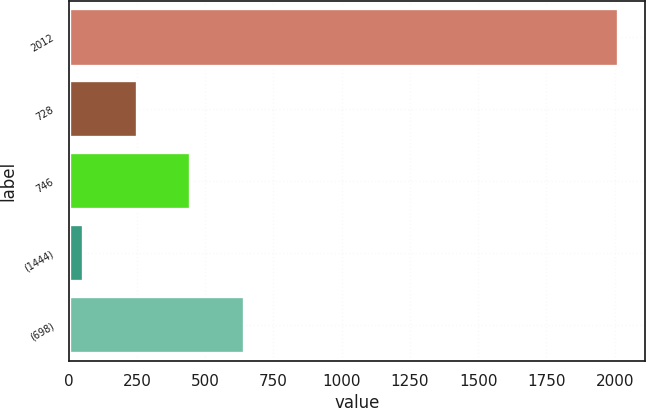Convert chart to OTSL. <chart><loc_0><loc_0><loc_500><loc_500><bar_chart><fcel>2012<fcel>728<fcel>746<fcel>(1444)<fcel>(698)<nl><fcel>2011<fcel>250.15<fcel>445.8<fcel>54.5<fcel>641.45<nl></chart> 